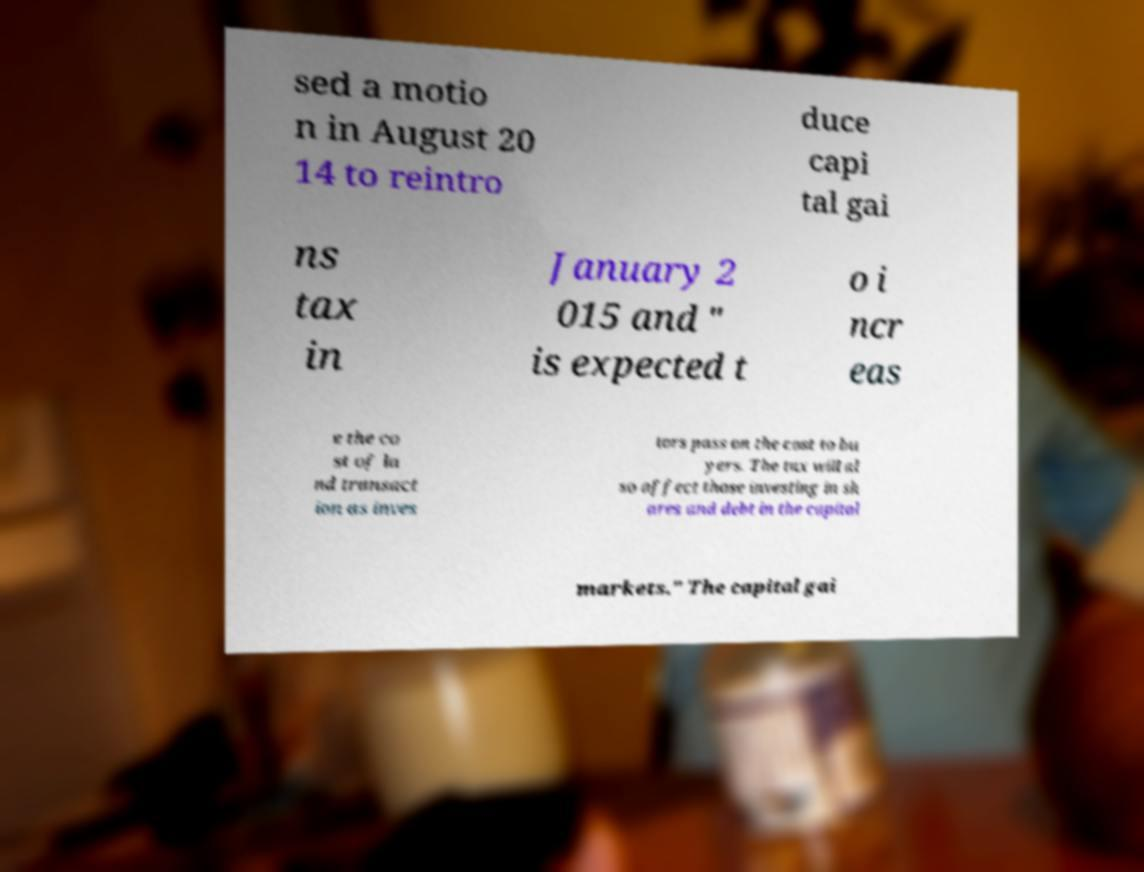I need the written content from this picture converted into text. Can you do that? sed a motio n in August 20 14 to reintro duce capi tal gai ns tax in January 2 015 and " is expected t o i ncr eas e the co st of la nd transact ion as inves tors pass on the cost to bu yers. The tax will al so affect those investing in sh ares and debt in the capital markets." The capital gai 